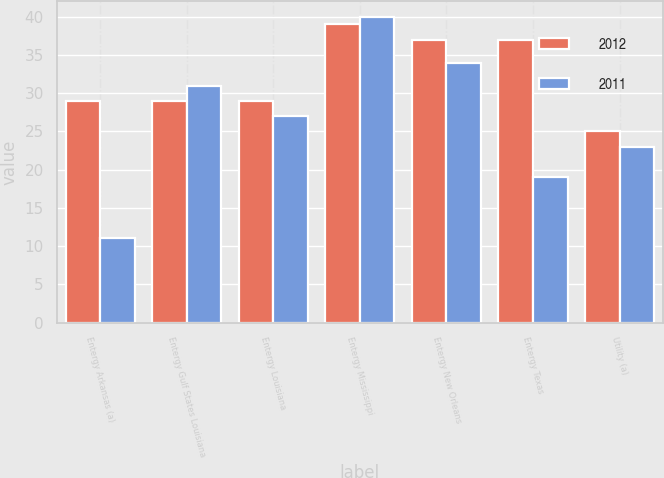Convert chart. <chart><loc_0><loc_0><loc_500><loc_500><stacked_bar_chart><ecel><fcel>Entergy Arkansas (a)<fcel>Entergy Gulf States Louisiana<fcel>Entergy Louisiana<fcel>Entergy Mississippi<fcel>Entergy New Orleans<fcel>Entergy Texas<fcel>Utility (a)<nl><fcel>2012<fcel>29<fcel>29<fcel>29<fcel>39<fcel>37<fcel>37<fcel>25<nl><fcel>2011<fcel>11<fcel>31<fcel>27<fcel>40<fcel>34<fcel>19<fcel>23<nl></chart> 